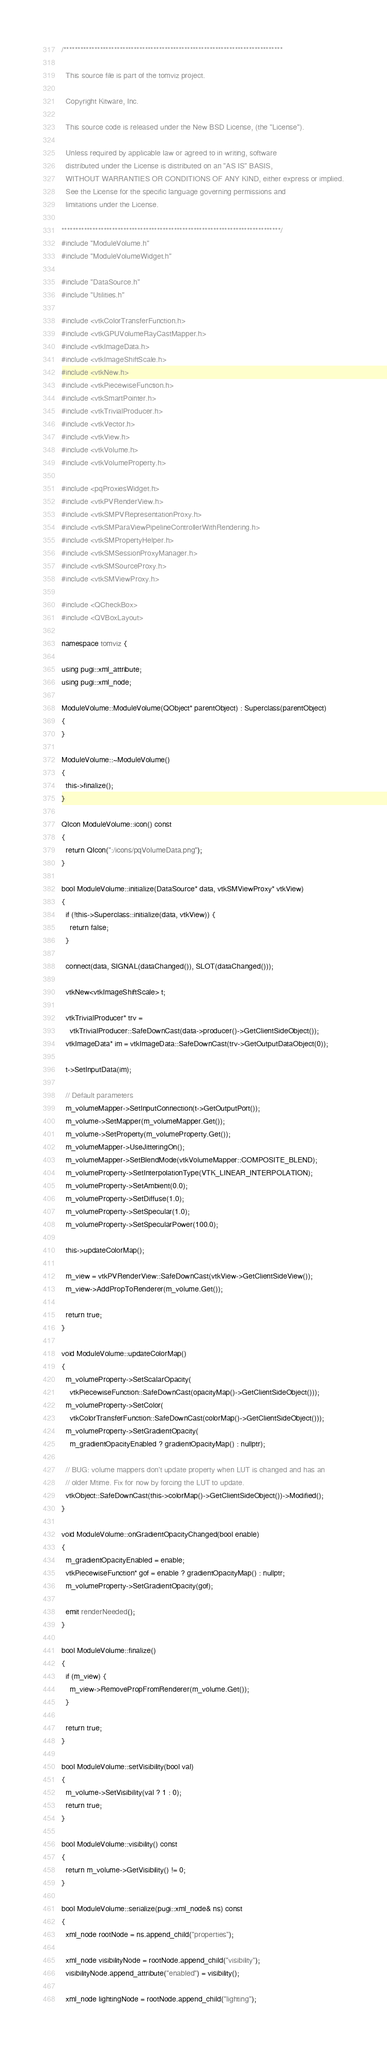<code> <loc_0><loc_0><loc_500><loc_500><_C++_>/******************************************************************************

  This source file is part of the tomviz project.

  Copyright Kitware, Inc.

  This source code is released under the New BSD License, (the "License").

  Unless required by applicable law or agreed to in writing, software
  distributed under the License is distributed on an "AS IS" BASIS,
  WITHOUT WARRANTIES OR CONDITIONS OF ANY KIND, either express or implied.
  See the License for the specific language governing permissions and
  limitations under the License.

******************************************************************************/
#include "ModuleVolume.h"
#include "ModuleVolumeWidget.h"

#include "DataSource.h"
#include "Utilities.h"

#include <vtkColorTransferFunction.h>
#include <vtkGPUVolumeRayCastMapper.h>
#include <vtkImageData.h>
#include <vtkImageShiftScale.h>
#include <vtkNew.h>
#include <vtkPiecewiseFunction.h>
#include <vtkSmartPointer.h>
#include <vtkTrivialProducer.h>
#include <vtkVector.h>
#include <vtkView.h>
#include <vtkVolume.h>
#include <vtkVolumeProperty.h>

#include <pqProxiesWidget.h>
#include <vtkPVRenderView.h>
#include <vtkSMPVRepresentationProxy.h>
#include <vtkSMParaViewPipelineControllerWithRendering.h>
#include <vtkSMPropertyHelper.h>
#include <vtkSMSessionProxyManager.h>
#include <vtkSMSourceProxy.h>
#include <vtkSMViewProxy.h>

#include <QCheckBox>
#include <QVBoxLayout>

namespace tomviz {

using pugi::xml_attribute;
using pugi::xml_node;

ModuleVolume::ModuleVolume(QObject* parentObject) : Superclass(parentObject)
{
}

ModuleVolume::~ModuleVolume()
{
  this->finalize();
}

QIcon ModuleVolume::icon() const
{
  return QIcon(":/icons/pqVolumeData.png");
}

bool ModuleVolume::initialize(DataSource* data, vtkSMViewProxy* vtkView)
{
  if (!this->Superclass::initialize(data, vtkView)) {
    return false;
  }

  connect(data, SIGNAL(dataChanged()), SLOT(dataChanged()));

  vtkNew<vtkImageShiftScale> t;

  vtkTrivialProducer* trv =
    vtkTrivialProducer::SafeDownCast(data->producer()->GetClientSideObject());
  vtkImageData* im = vtkImageData::SafeDownCast(trv->GetOutputDataObject(0));

  t->SetInputData(im);

  // Default parameters
  m_volumeMapper->SetInputConnection(t->GetOutputPort());
  m_volume->SetMapper(m_volumeMapper.Get());
  m_volume->SetProperty(m_volumeProperty.Get());
  m_volumeMapper->UseJitteringOn();
  m_volumeMapper->SetBlendMode(vtkVolumeMapper::COMPOSITE_BLEND);
  m_volumeProperty->SetInterpolationType(VTK_LINEAR_INTERPOLATION);
  m_volumeProperty->SetAmbient(0.0);
  m_volumeProperty->SetDiffuse(1.0);
  m_volumeProperty->SetSpecular(1.0);
  m_volumeProperty->SetSpecularPower(100.0);

  this->updateColorMap();

  m_view = vtkPVRenderView::SafeDownCast(vtkView->GetClientSideView());
  m_view->AddPropToRenderer(m_volume.Get());

  return true;
}

void ModuleVolume::updateColorMap()
{
  m_volumeProperty->SetScalarOpacity(
    vtkPiecewiseFunction::SafeDownCast(opacityMap()->GetClientSideObject()));
  m_volumeProperty->SetColor(
    vtkColorTransferFunction::SafeDownCast(colorMap()->GetClientSideObject()));
  m_volumeProperty->SetGradientOpacity(
    m_gradientOpacityEnabled ? gradientOpacityMap() : nullptr);

  // BUG: volume mappers don't update property when LUT is changed and has an
  // older Mtime. Fix for now by forcing the LUT to update.
  vtkObject::SafeDownCast(this->colorMap()->GetClientSideObject())->Modified();
}

void ModuleVolume::onGradientOpacityChanged(bool enable)
{
  m_gradientOpacityEnabled = enable;
  vtkPiecewiseFunction* gof = enable ? gradientOpacityMap() : nullptr;
  m_volumeProperty->SetGradientOpacity(gof);

  emit renderNeeded();
}

bool ModuleVolume::finalize()
{
  if (m_view) {
    m_view->RemovePropFromRenderer(m_volume.Get());
  }

  return true;
}

bool ModuleVolume::setVisibility(bool val)
{
  m_volume->SetVisibility(val ? 1 : 0);
  return true;
}

bool ModuleVolume::visibility() const
{
  return m_volume->GetVisibility() != 0;
}

bool ModuleVolume::serialize(pugi::xml_node& ns) const
{
  xml_node rootNode = ns.append_child("properties");

  xml_node visibilityNode = rootNode.append_child("visibility");
  visibilityNode.append_attribute("enabled") = visibility();

  xml_node lightingNode = rootNode.append_child("lighting");</code> 